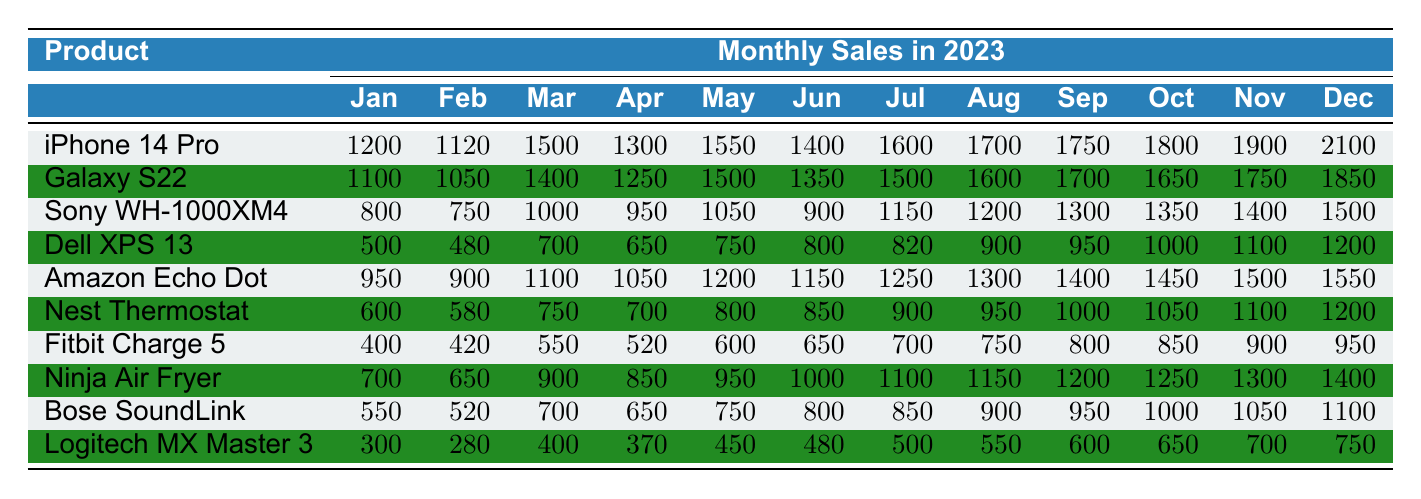What was the total sales of the Apple iPhone 14 Pro in 2023? To find the total sales of the Apple iPhone 14 Pro, I can add the monthly sales from January to December: 1200 + 1120 + 1500 + 1300 + 1550 + 1400 + 1600 + 1700 + 1750 + 1800 + 1900 + 2100 = 18,220.
Answer: 18220 Which product had the highest sales in December? Looking at the December sales, I can see that the Apple iPhone 14 Pro had sales of 2100, while other products had lower sales amounts. Therefore, the iPhone 14 Pro had the highest sales in December.
Answer: Apple iPhone 14 Pro What is the average monthly sales of the Samsung Galaxy S22 in 2023? The average monthly sales for the Samsung Galaxy S22 can be calculated by summing its monthly sales: 1100 + 1050 + 1400 + 1250 + 1500 + 1350 + 1500 + 1600 + 1700 + 1650 + 1750 + 1850 = 17,900. Since there are 12 months, the average is 17,900 / 12 = 1,491.67.
Answer: 1491.67 Did any product sell less than 500 units in January? The products that sold in January were: iPhone 14 Pro (1200), Galaxy S22 (1100), Sony WH-1000XM4 (800), Dell XPS 13 (500), Amazon Echo Dot (950), Nest Thermostat (600), Fitbit Charge 5 (400), Ninja Air Fryer (700), Bose SoundLink (550), and Logitech MX Master 3 (300). The Logitech MX Master 3 sold 300 units, which is less than 500. Thus, the answer is yes.
Answer: Yes What was the increase in sales of the Google Nest Thermostat from March to October? The sales for the Google Nest Thermostat in March was 750 and in October was 1050. The increase can be calculated by subtracting the March sales from the October sales: 1050 - 750 = 300.
Answer: 300 Which product showed the most consistent growth in sales over the year? To determine consistency in sales growth, I can observe the monthly sales of each product. The product that showed consistent month-over-month increases is the Apple iPhone 14 Pro, which had rising sales from January to December without any decrease.
Answer: Apple iPhone 14 Pro What was the total sales of all products combined in June? To find the total sales in June, I will add the sales of each product: 1400 (iPhone 14 Pro) + 1350 (Galaxy S22) + 900 (Sony WH-1000XM4) + 800 (Dell XPS 13) + 1150 (Amazon Echo Dot) + 850 (Nest Thermostat) + 650 (Fitbit Charge 5) + 1000 (Ninja Air Fryer) + 800 (Bose SoundLink) + 480 (Logitech MX Master 3) = 10,280.
Answer: 10280 Is the total sales of the Dell XPS 13 higher than that of the Fitbit Charge 5? The total sales for Dell XPS 13 calculated from January to December is 500 + 480 + 700 + 650 + 750 + 800 + 820 + 900 + 950 + 1000 + 1100 + 1200 = 10,020. For Fitbit Charge 5, the total is 400 + 420 + 550 + 520 + 600 + 650 + 700 + 750 + 800 + 850 + 900 + 950 = 8,250. Since 10,020 is greater than 8,250, the answer is yes.
Answer: Yes What is the difference in sales between the highest and lowest selling product in November? The highest selling product in November is the Apple iPhone 14 Pro with sales of 1900, and the lowest selling product is the Logitech MX Master 3 with sales of 700. The difference is calculated as 1900 - 700 = 1200.
Answer: 1200 